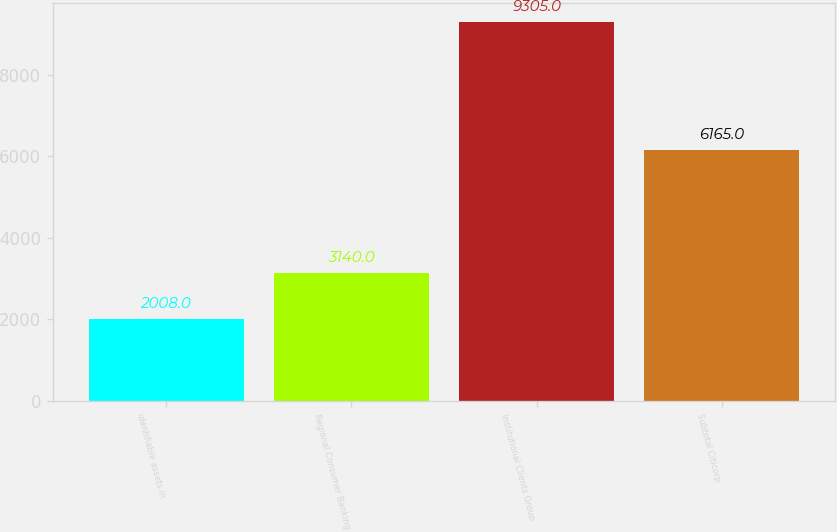<chart> <loc_0><loc_0><loc_500><loc_500><bar_chart><fcel>identifiable assets in<fcel>Regional Consumer Banking<fcel>Institutional Clients Group<fcel>Subtotal Citicorp<nl><fcel>2008<fcel>3140<fcel>9305<fcel>6165<nl></chart> 